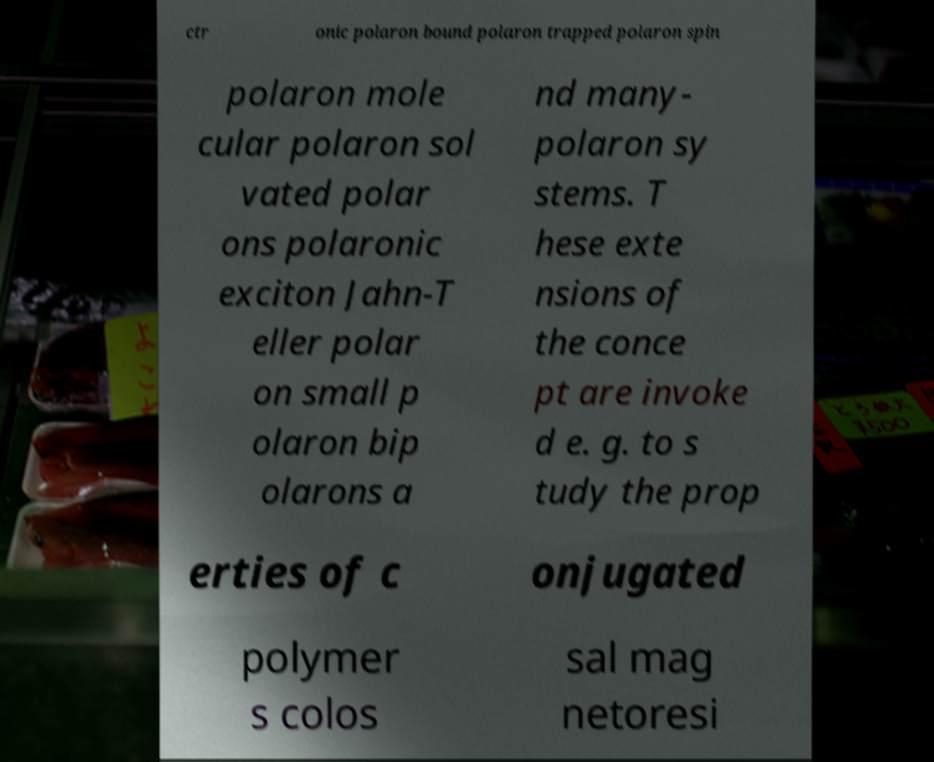There's text embedded in this image that I need extracted. Can you transcribe it verbatim? ctr onic polaron bound polaron trapped polaron spin polaron mole cular polaron sol vated polar ons polaronic exciton Jahn-T eller polar on small p olaron bip olarons a nd many- polaron sy stems. T hese exte nsions of the conce pt are invoke d e. g. to s tudy the prop erties of c onjugated polymer s colos sal mag netoresi 